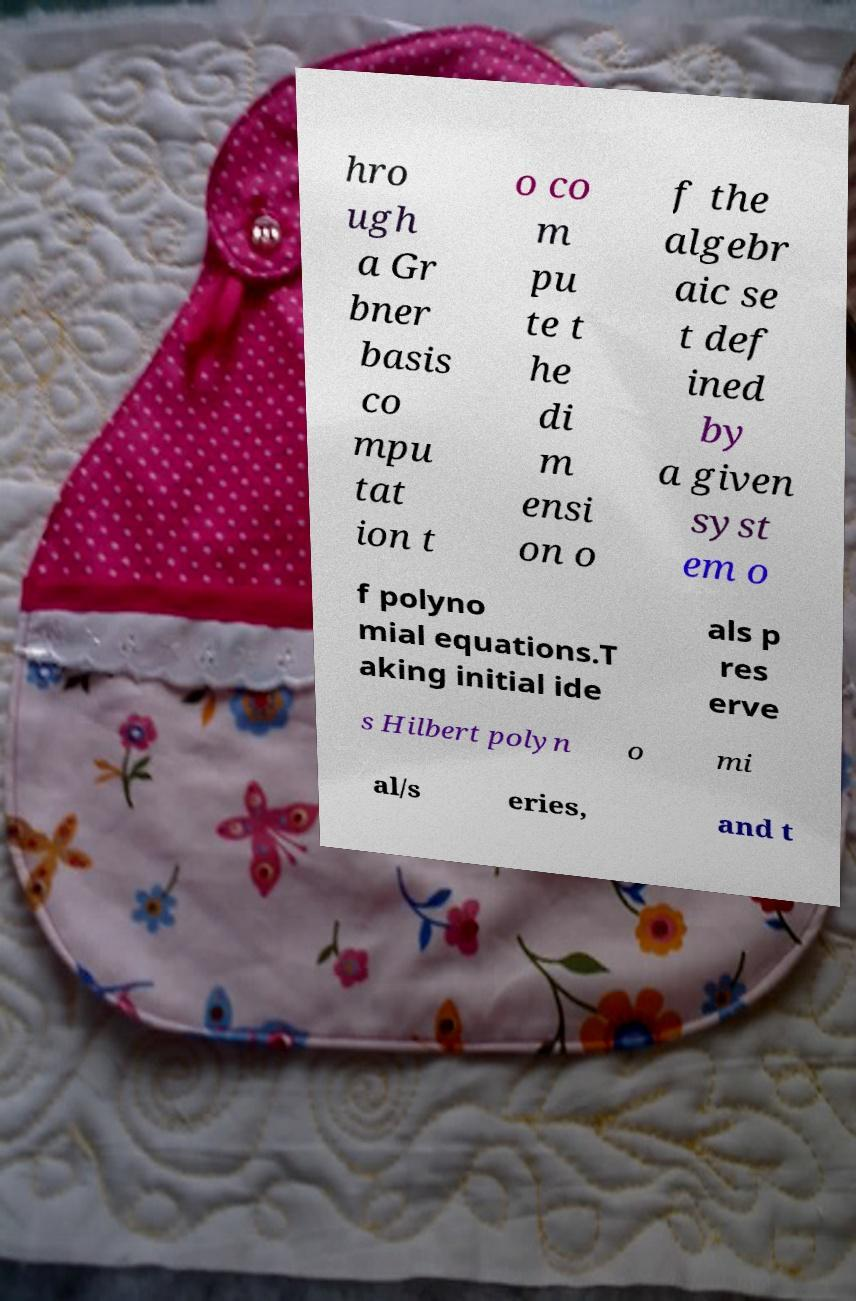Can you read and provide the text displayed in the image?This photo seems to have some interesting text. Can you extract and type it out for me? hro ugh a Gr bner basis co mpu tat ion t o co m pu te t he di m ensi on o f the algebr aic se t def ined by a given syst em o f polyno mial equations.T aking initial ide als p res erve s Hilbert polyn o mi al/s eries, and t 